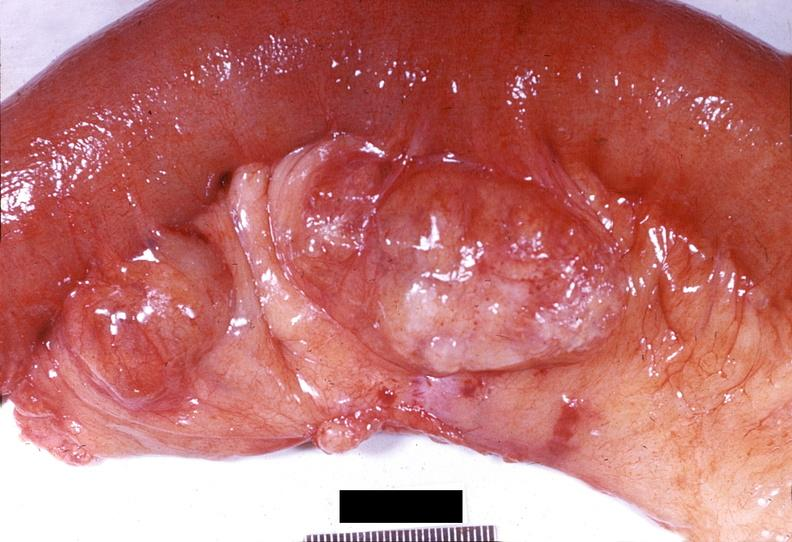where does this belong to?
Answer the question using a single word or phrase. Gastrointestinal system 